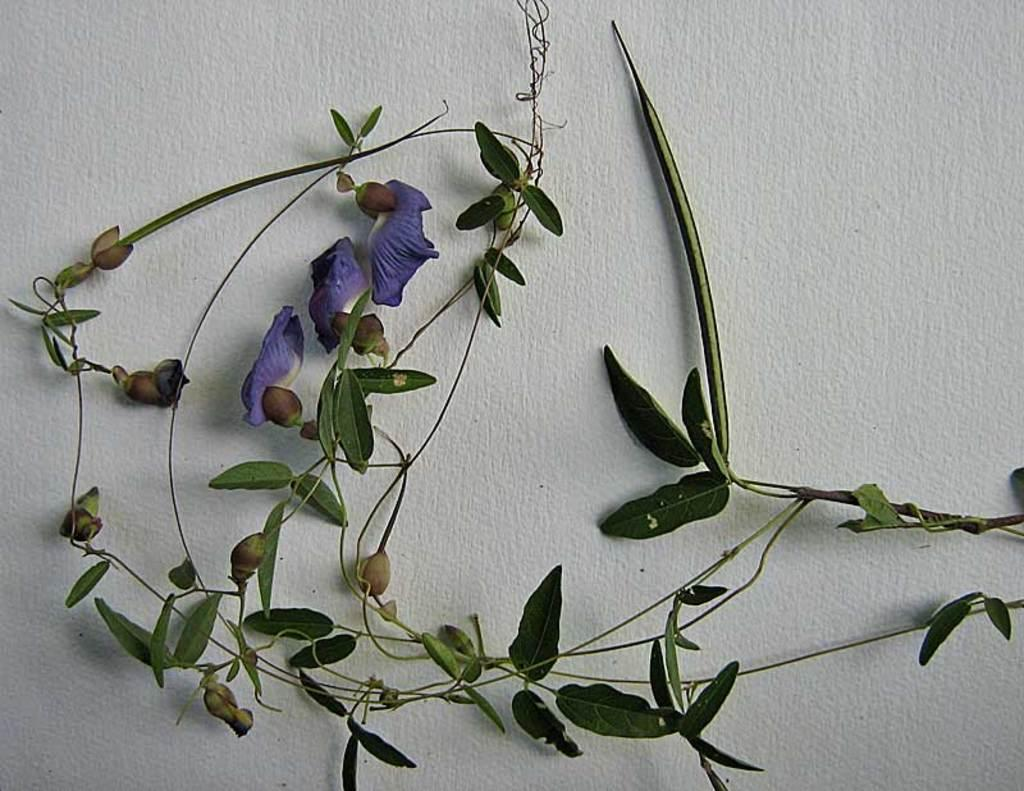What type of decorations are on the wall in the image? There are leaves and flowers on the wall in the image. Can you describe the colors of the decorations on the wall? The colors of the decorations on the wall cannot be determined from the provided facts. What type of surprise can be seen in the image? There is no surprise present in the image; it features leaves and flowers on the wall. What type of quartz is visible in the image? There is no quartz present in the image. 